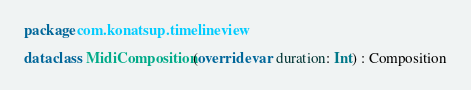Convert code to text. <code><loc_0><loc_0><loc_500><loc_500><_Kotlin_>package com.konatsup.timelineview

data class MidiComposition(override var duration: Int) : Composition</code> 